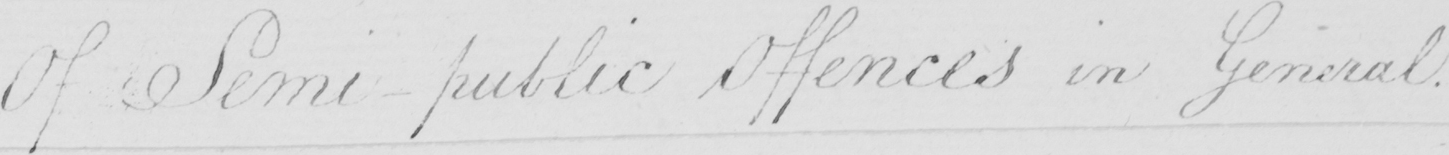Can you read and transcribe this handwriting? Of Semi-public Offences in General . 